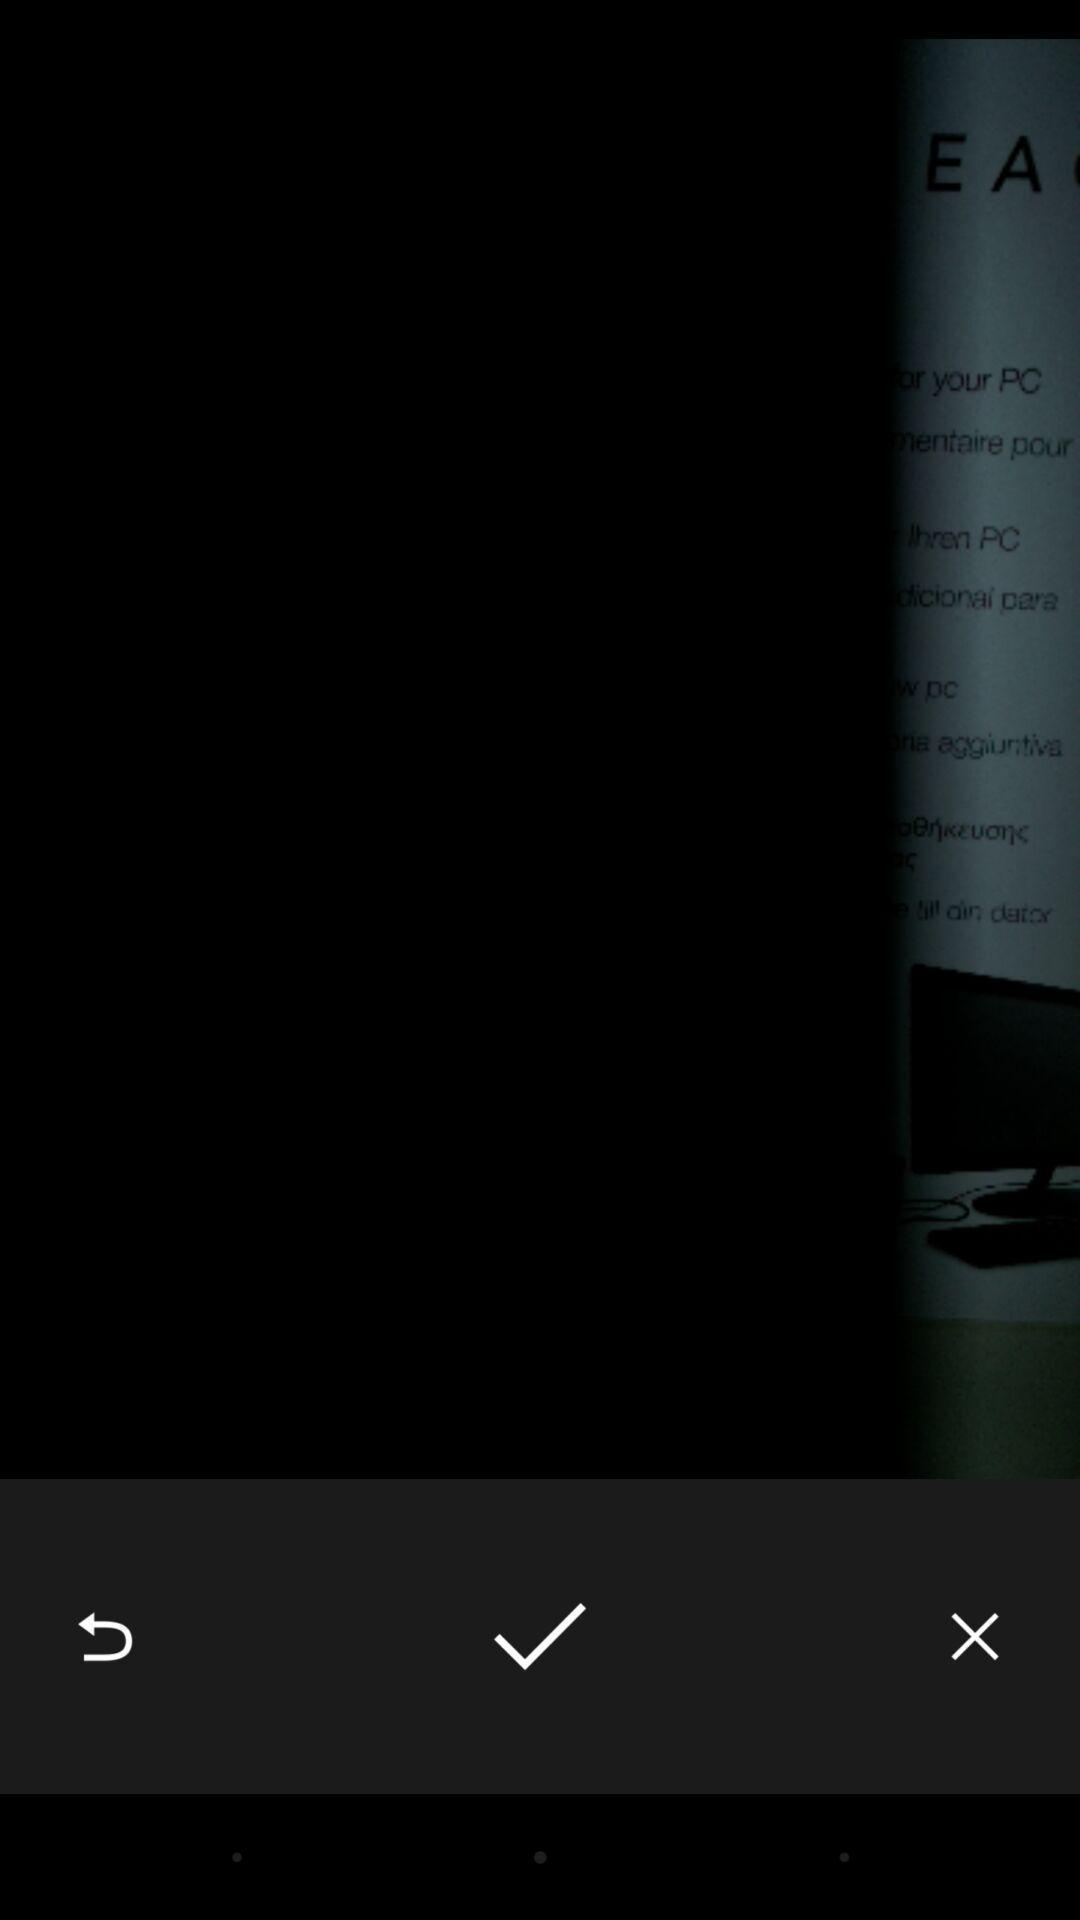Explain the elements present in this screenshot. Page shows options for saving an image on study app. 